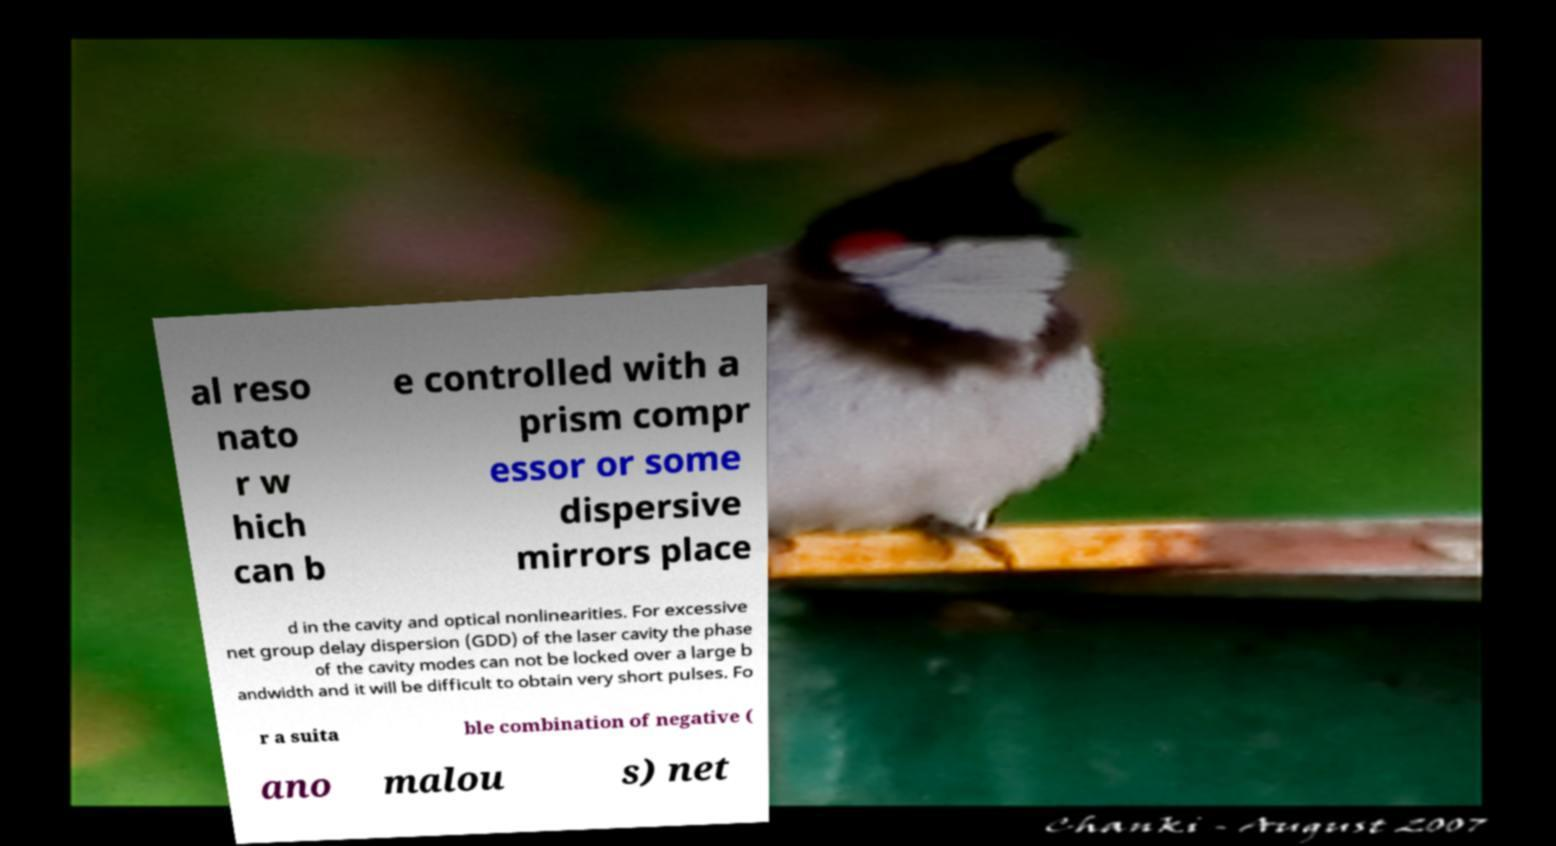What messages or text are displayed in this image? I need them in a readable, typed format. al reso nato r w hich can b e controlled with a prism compr essor or some dispersive mirrors place d in the cavity and optical nonlinearities. For excessive net group delay dispersion (GDD) of the laser cavity the phase of the cavity modes can not be locked over a large b andwidth and it will be difficult to obtain very short pulses. Fo r a suita ble combination of negative ( ano malou s) net 